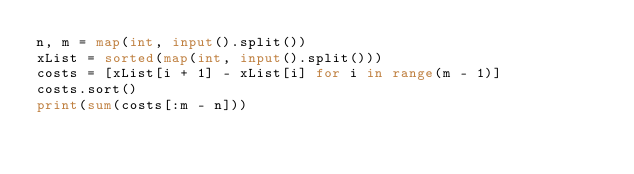Convert code to text. <code><loc_0><loc_0><loc_500><loc_500><_Python_>n, m = map(int, input().split())
xList = sorted(map(int, input().split()))
costs = [xList[i + 1] - xList[i] for i in range(m - 1)]
costs.sort()
print(sum(costs[:m - n]))
</code> 